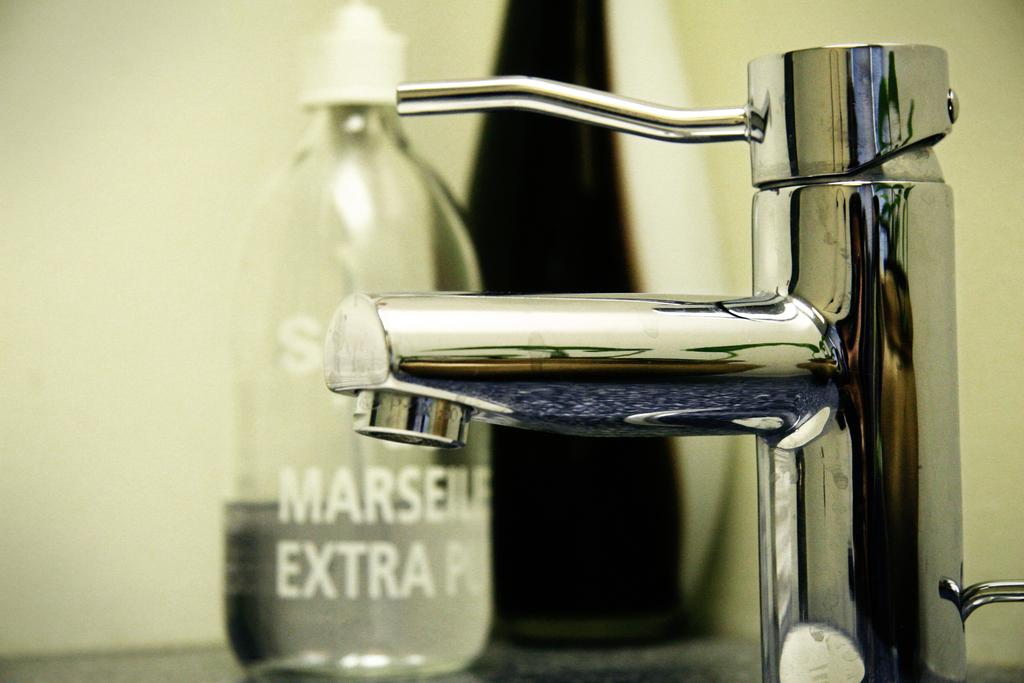<image>
Provide a brief description of the given image. A bottle next to a sink is labelled "Marseille." 